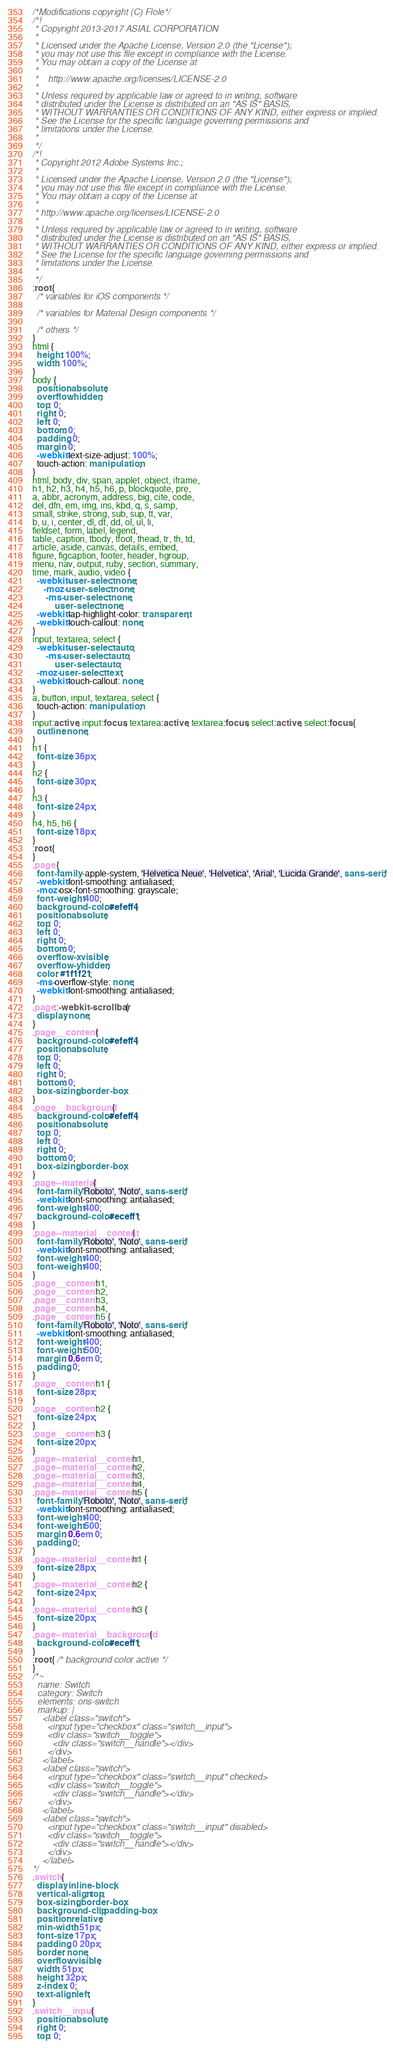Convert code to text. <code><loc_0><loc_0><loc_500><loc_500><_CSS_>/*Modifications copyright (C) Flole*/
/*!
 * Copyright 2013-2017 ASIAL CORPORATION
 *
 * Licensed under the Apache License, Version 2.0 (the "License");
 * you may not use this file except in compliance with the License.
 * You may obtain a copy of the License at
 *
 *    http://www.apache.org/licenses/LICENSE-2.0
 *
 * Unless required by applicable law or agreed to in writing, software
 * distributed under the License is distributed on an "AS IS" BASIS,
 * WITHOUT WARRANTIES OR CONDITIONS OF ANY KIND, either express or implied.
 * See the License for the specific language governing permissions and
 * limitations under the License.
 *
 */
/*!
 * Copyright 2012 Adobe Systems Inc.;
 *
 * Licensed under the Apache License, Version 2.0 (the "License");
 * you may not use this file except in compliance with the License.
 * You may obtain a copy of the License at
 *
 * http://www.apache.org/licenses/LICENSE-2.0
 *
 * Unless required by applicable law or agreed to in writing, software
 * distributed under the License is distributed on an "AS IS" BASIS,
 * WITHOUT WARRANTIES OR CONDITIONS OF ANY KIND, either express or implied.
 * See the License for the specific language governing permissions and
 * limitations under the License.
 *
 */
:root {
  /* variables for iOS components */

  /* variables for Material Design components */

  /* others */
}
html {
  height: 100%;
  width: 100%;
}
body {
  position: absolute;
  overflow: hidden;
  top: 0;
  right: 0;
  left: 0;
  bottom: 0;
  padding: 0;
  margin: 0;
  -webkit-text-size-adjust: 100%;
  touch-action: manipulation;
}
html, body, div, span, applet, object, iframe,
h1, h2, h3, h4, h5, h6, p, blockquote, pre,
a, abbr, acronym, address, big, cite, code,
del, dfn, em, img, ins, kbd, q, s, samp,
small, strike, strong, sub, sup, tt, var,
b, u, i, center, dl, dt, dd, ol, ul, li,
fieldset, form, label, legend,
table, caption, tbody, tfoot, thead, tr, th, td,
article, aside, canvas, details, embed,
figure, figcaption, footer, header, hgroup,
menu, nav, output, ruby, section, summary,
time, mark, audio, video {
  -webkit-user-select: none;
     -moz-user-select: none;
      -ms-user-select: none;
          user-select: none;
  -webkit-tap-highlight-color: transparent;
  -webkit-touch-callout: none;
}
input, textarea, select {
  -webkit-user-select: auto;
      -ms-user-select: auto;
          user-select: auto;
  -moz-user-select: text;
  -webkit-touch-callout: none;
}
a, button, input, textarea, select {
  touch-action: manipulation;
}
input:active, input:focus, textarea:active, textarea:focus, select:active, select:focus {
  outline: none;
}
h1 {
  font-size: 36px;
}
h2 {
  font-size: 30px;
}
h3 {
  font-size: 24px;
}
h4, h5, h6 {
  font-size: 18px;
}
:root {
}
.page {
  font-family: -apple-system, 'Helvetica Neue', 'Helvetica', 'Arial', 'Lucida Grande', sans-serif;
  -webkit-font-smoothing: antialiased;
  -moz-osx-font-smoothing: grayscale;
  font-weight: 400;
  background-color: #efeff4;
  position: absolute;
  top: 0;
  left: 0;
  right: 0;
  bottom: 0;
  overflow-x: visible;
  overflow-y: hidden;
  color: #1f1f21;
  -ms-overflow-style: none;
  -webkit-font-smoothing: antialiased;
}
.page::-webkit-scrollbar {
  display: none;
}
.page__content {
  background-color: #efeff4;
  position: absolute;
  top: 0;
  left: 0;
  right: 0;
  bottom: 0;
  box-sizing: border-box;
}
.page__background {
  background-color: #efeff4;
  position: absolute;
  top: 0;
  left: 0;
  right: 0;
  bottom: 0;
  box-sizing: border-box;
}
.page--material {
  font-family: 'Roboto', 'Noto', sans-serif;
  -webkit-font-smoothing: antialiased;
  font-weight: 400;
  background-color: #eceff1;
}
.page--material__content {
  font-family: 'Roboto', 'Noto', sans-serif;
  -webkit-font-smoothing: antialiased;
  font-weight: 400;
  font-weight: 400;
}
.page__content h1,
.page__content h2,
.page__content h3,
.page__content h4,
.page__content h5 {
  font-family: 'Roboto', 'Noto', sans-serif;
  -webkit-font-smoothing: antialiased;
  font-weight: 400;
  font-weight: 500;
  margin: 0.6em 0;
  padding: 0;
}
.page__content h1 {
  font-size: 28px;
}
.page__content h2 {
  font-size: 24px;
}
.page__content h3 {
  font-size: 20px;
}
.page--material__content h1,
.page--material__content h2,
.page--material__content h3,
.page--material__content h4,
.page--material__content h5 {
  font-family: 'Roboto', 'Noto', sans-serif;
  -webkit-font-smoothing: antialiased;
  font-weight: 400;
  font-weight: 500;
  margin: 0.6em 0;
  padding: 0;
}
.page--material__content h1 {
  font-size: 28px;
}
.page--material__content h2 {
  font-size: 24px;
}
.page--material__content h3 {
  font-size: 20px;
}
.page--material__background {
  background-color: #eceff1;
}
:root { /* background color active */
}
/*~
  name: Switch
  category: Switch
  elements: ons-switch
  markup: |
    <label class="switch">
      <input type="checkbox" class="switch__input">
      <div class="switch__toggle">
        <div class="switch__handle"></div>
      </div>
    </label>
    <label class="switch">
      <input type="checkbox" class="switch__input" checked>
      <div class="switch__toggle">
        <div class="switch__handle"></div>
      </div>
    </label>
    <label class="switch">
      <input type="checkbox" class="switch__input" disabled>
      <div class="switch__toggle">
        <div class="switch__handle"></div>
      </div>
    </label>
*/
.switch {
  display: inline-block;
  vertical-align: top;
  box-sizing: border-box;
  background-clip: padding-box;
  position: relative;
  min-width: 51px;
  font-size: 17px;
  padding: 0 20px;
  border: none;
  overflow: visible;
  width: 51px;
  height: 32px;
  z-index: 0;
  text-align: left;
}
.switch__input {
  position: absolute;
  right: 0;
  top: 0;</code> 